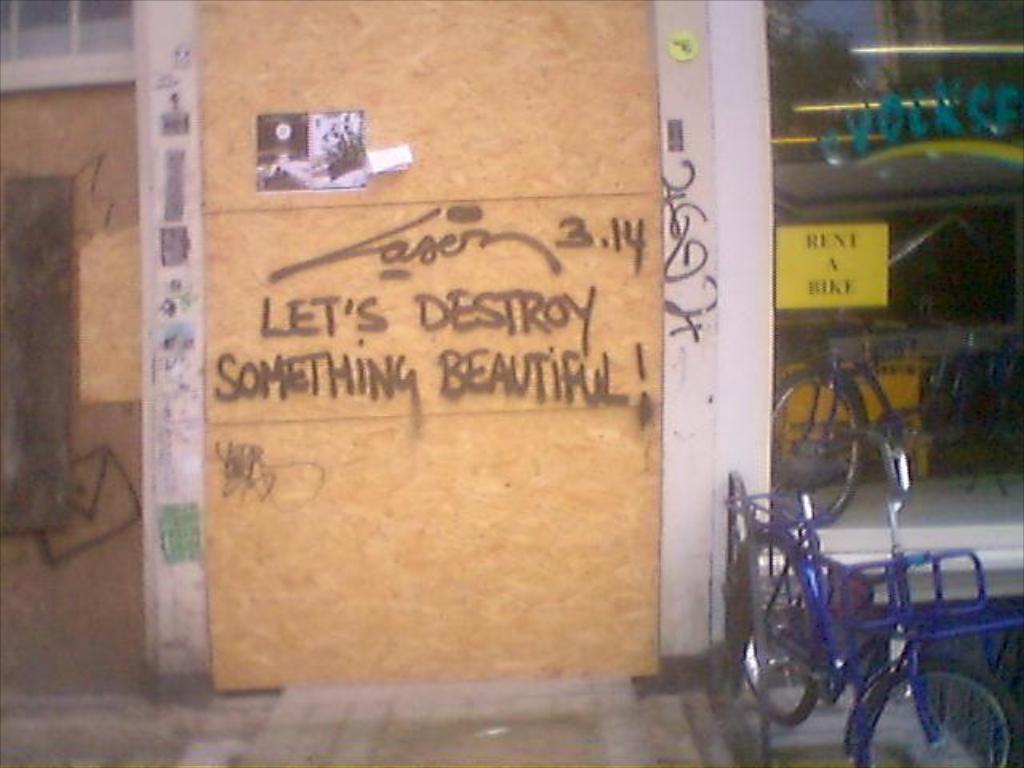In one or two sentences, can you explain what this image depicts? In this image, we can see a board and there is some text on it. In the background, we can see a poster on the glass door and there are some vehicles and there is a wall. 